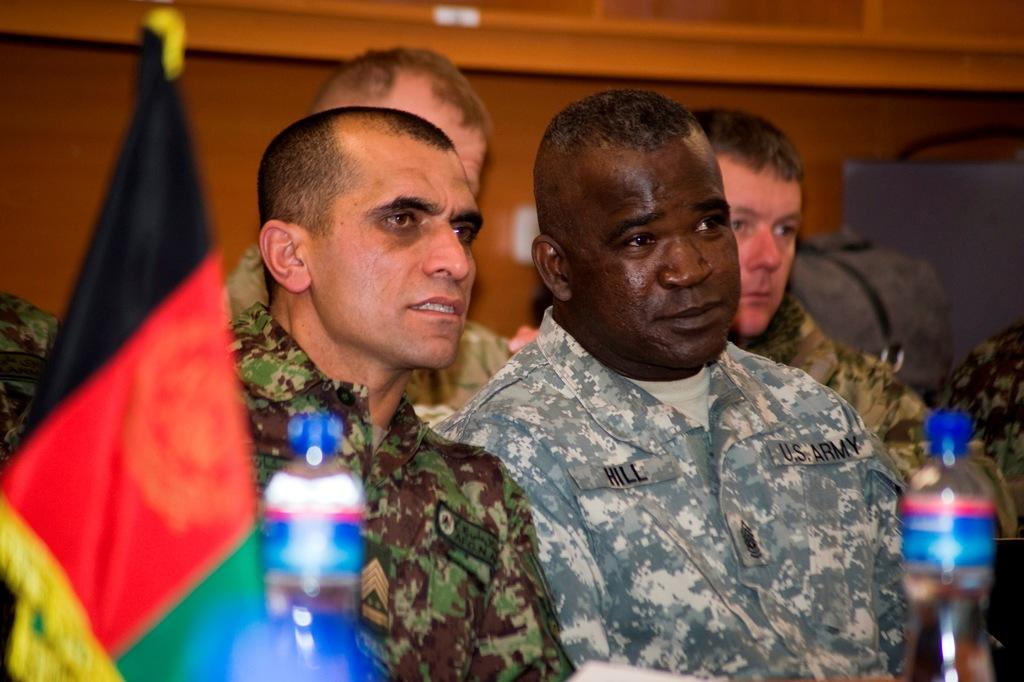What is the main subject of the image? The main subject of the image is a group of people. What are the people doing in the image? The people are sitting on chairs in the image. What is present on the table in the image? There is a bottle on the table in the image. What can be seen in the background of the image? There is a flag in the background of the image. What type of ray can be seen swimming in the image? There is no ray present in the image; it features a group of people sitting on chairs with a table and a flag in the background. What kind of thunder can be heard in the image? There is no sound, including thunder, present in the image, as it is a still photograph. 